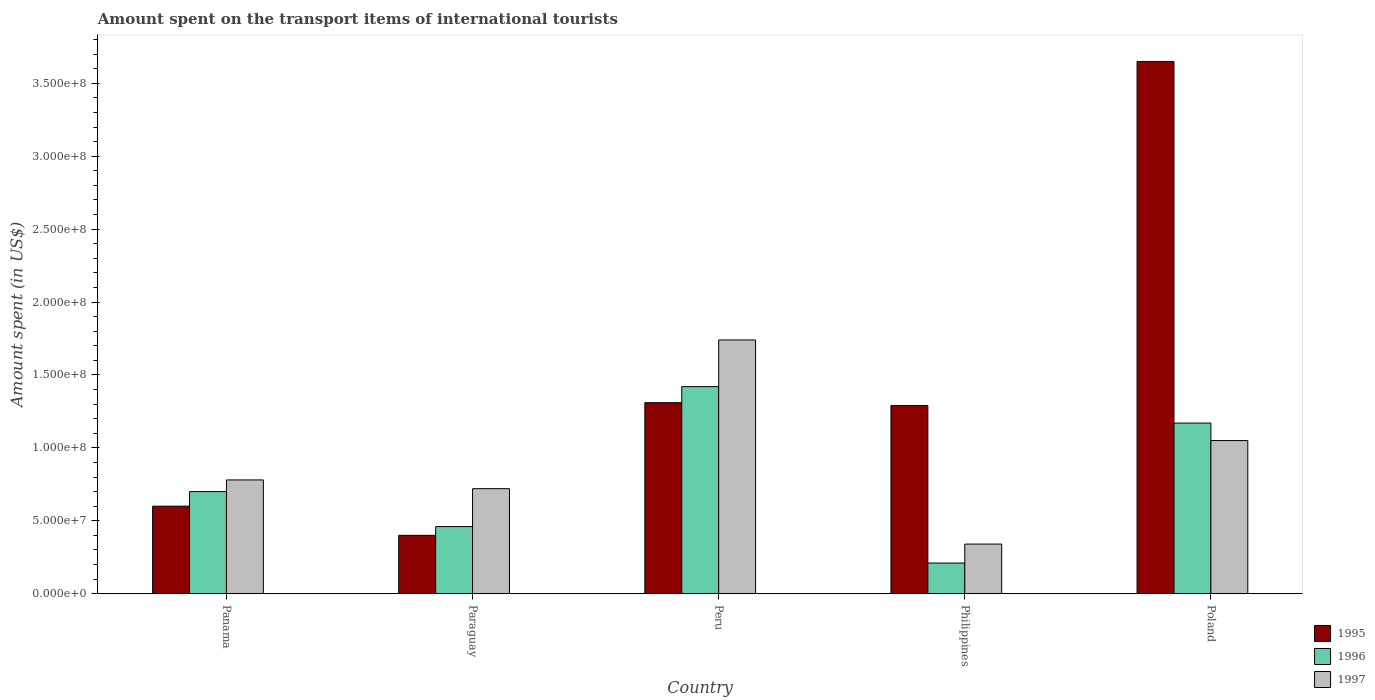Are the number of bars on each tick of the X-axis equal?
Keep it short and to the point. Yes. In how many cases, is the number of bars for a given country not equal to the number of legend labels?
Give a very brief answer. 0. What is the amount spent on the transport items of international tourists in 1996 in Philippines?
Your answer should be compact. 2.10e+07. Across all countries, what is the maximum amount spent on the transport items of international tourists in 1996?
Offer a very short reply. 1.42e+08. Across all countries, what is the minimum amount spent on the transport items of international tourists in 1995?
Your answer should be compact. 4.00e+07. What is the total amount spent on the transport items of international tourists in 1997 in the graph?
Provide a short and direct response. 4.63e+08. What is the difference between the amount spent on the transport items of international tourists in 1996 in Paraguay and that in Peru?
Provide a short and direct response. -9.60e+07. What is the difference between the amount spent on the transport items of international tourists in 1995 in Paraguay and the amount spent on the transport items of international tourists in 1997 in Poland?
Offer a terse response. -6.50e+07. What is the average amount spent on the transport items of international tourists in 1997 per country?
Provide a short and direct response. 9.26e+07. What is the difference between the amount spent on the transport items of international tourists of/in 1997 and amount spent on the transport items of international tourists of/in 1995 in Philippines?
Give a very brief answer. -9.50e+07. What is the ratio of the amount spent on the transport items of international tourists in 1996 in Peru to that in Philippines?
Give a very brief answer. 6.76. Is the difference between the amount spent on the transport items of international tourists in 1997 in Panama and Philippines greater than the difference between the amount spent on the transport items of international tourists in 1995 in Panama and Philippines?
Keep it short and to the point. Yes. What is the difference between the highest and the second highest amount spent on the transport items of international tourists in 1995?
Ensure brevity in your answer.  2.36e+08. What is the difference between the highest and the lowest amount spent on the transport items of international tourists in 1996?
Make the answer very short. 1.21e+08. In how many countries, is the amount spent on the transport items of international tourists in 1995 greater than the average amount spent on the transport items of international tourists in 1995 taken over all countries?
Keep it short and to the point. 1. Is the sum of the amount spent on the transport items of international tourists in 1997 in Panama and Poland greater than the maximum amount spent on the transport items of international tourists in 1995 across all countries?
Keep it short and to the point. No. What does the 3rd bar from the right in Panama represents?
Your answer should be very brief. 1995. Is it the case that in every country, the sum of the amount spent on the transport items of international tourists in 1997 and amount spent on the transport items of international tourists in 1995 is greater than the amount spent on the transport items of international tourists in 1996?
Offer a terse response. Yes. How many bars are there?
Offer a terse response. 15. What is the difference between two consecutive major ticks on the Y-axis?
Ensure brevity in your answer.  5.00e+07. What is the title of the graph?
Make the answer very short. Amount spent on the transport items of international tourists. Does "2006" appear as one of the legend labels in the graph?
Keep it short and to the point. No. What is the label or title of the X-axis?
Provide a short and direct response. Country. What is the label or title of the Y-axis?
Provide a short and direct response. Amount spent (in US$). What is the Amount spent (in US$) of 1995 in Panama?
Ensure brevity in your answer.  6.00e+07. What is the Amount spent (in US$) of 1996 in Panama?
Offer a very short reply. 7.00e+07. What is the Amount spent (in US$) in 1997 in Panama?
Keep it short and to the point. 7.80e+07. What is the Amount spent (in US$) of 1995 in Paraguay?
Keep it short and to the point. 4.00e+07. What is the Amount spent (in US$) in 1996 in Paraguay?
Offer a terse response. 4.60e+07. What is the Amount spent (in US$) of 1997 in Paraguay?
Ensure brevity in your answer.  7.20e+07. What is the Amount spent (in US$) of 1995 in Peru?
Provide a short and direct response. 1.31e+08. What is the Amount spent (in US$) in 1996 in Peru?
Ensure brevity in your answer.  1.42e+08. What is the Amount spent (in US$) of 1997 in Peru?
Keep it short and to the point. 1.74e+08. What is the Amount spent (in US$) in 1995 in Philippines?
Ensure brevity in your answer.  1.29e+08. What is the Amount spent (in US$) in 1996 in Philippines?
Your response must be concise. 2.10e+07. What is the Amount spent (in US$) of 1997 in Philippines?
Offer a very short reply. 3.40e+07. What is the Amount spent (in US$) in 1995 in Poland?
Provide a short and direct response. 3.65e+08. What is the Amount spent (in US$) in 1996 in Poland?
Provide a short and direct response. 1.17e+08. What is the Amount spent (in US$) in 1997 in Poland?
Offer a very short reply. 1.05e+08. Across all countries, what is the maximum Amount spent (in US$) in 1995?
Your response must be concise. 3.65e+08. Across all countries, what is the maximum Amount spent (in US$) in 1996?
Your answer should be compact. 1.42e+08. Across all countries, what is the maximum Amount spent (in US$) of 1997?
Ensure brevity in your answer.  1.74e+08. Across all countries, what is the minimum Amount spent (in US$) in 1995?
Your response must be concise. 4.00e+07. Across all countries, what is the minimum Amount spent (in US$) in 1996?
Offer a very short reply. 2.10e+07. Across all countries, what is the minimum Amount spent (in US$) of 1997?
Give a very brief answer. 3.40e+07. What is the total Amount spent (in US$) in 1995 in the graph?
Provide a succinct answer. 7.25e+08. What is the total Amount spent (in US$) of 1996 in the graph?
Offer a very short reply. 3.96e+08. What is the total Amount spent (in US$) in 1997 in the graph?
Make the answer very short. 4.63e+08. What is the difference between the Amount spent (in US$) of 1995 in Panama and that in Paraguay?
Provide a succinct answer. 2.00e+07. What is the difference between the Amount spent (in US$) of 1996 in Panama and that in Paraguay?
Give a very brief answer. 2.40e+07. What is the difference between the Amount spent (in US$) in 1997 in Panama and that in Paraguay?
Ensure brevity in your answer.  6.00e+06. What is the difference between the Amount spent (in US$) of 1995 in Panama and that in Peru?
Offer a very short reply. -7.10e+07. What is the difference between the Amount spent (in US$) of 1996 in Panama and that in Peru?
Offer a very short reply. -7.20e+07. What is the difference between the Amount spent (in US$) in 1997 in Panama and that in Peru?
Provide a succinct answer. -9.60e+07. What is the difference between the Amount spent (in US$) of 1995 in Panama and that in Philippines?
Provide a succinct answer. -6.90e+07. What is the difference between the Amount spent (in US$) in 1996 in Panama and that in Philippines?
Keep it short and to the point. 4.90e+07. What is the difference between the Amount spent (in US$) in 1997 in Panama and that in Philippines?
Your answer should be compact. 4.40e+07. What is the difference between the Amount spent (in US$) of 1995 in Panama and that in Poland?
Keep it short and to the point. -3.05e+08. What is the difference between the Amount spent (in US$) of 1996 in Panama and that in Poland?
Your answer should be compact. -4.70e+07. What is the difference between the Amount spent (in US$) in 1997 in Panama and that in Poland?
Your answer should be compact. -2.70e+07. What is the difference between the Amount spent (in US$) in 1995 in Paraguay and that in Peru?
Your answer should be compact. -9.10e+07. What is the difference between the Amount spent (in US$) in 1996 in Paraguay and that in Peru?
Give a very brief answer. -9.60e+07. What is the difference between the Amount spent (in US$) in 1997 in Paraguay and that in Peru?
Give a very brief answer. -1.02e+08. What is the difference between the Amount spent (in US$) of 1995 in Paraguay and that in Philippines?
Your answer should be compact. -8.90e+07. What is the difference between the Amount spent (in US$) of 1996 in Paraguay and that in Philippines?
Offer a very short reply. 2.50e+07. What is the difference between the Amount spent (in US$) of 1997 in Paraguay and that in Philippines?
Provide a succinct answer. 3.80e+07. What is the difference between the Amount spent (in US$) of 1995 in Paraguay and that in Poland?
Make the answer very short. -3.25e+08. What is the difference between the Amount spent (in US$) in 1996 in Paraguay and that in Poland?
Your answer should be very brief. -7.10e+07. What is the difference between the Amount spent (in US$) of 1997 in Paraguay and that in Poland?
Make the answer very short. -3.30e+07. What is the difference between the Amount spent (in US$) in 1995 in Peru and that in Philippines?
Give a very brief answer. 2.00e+06. What is the difference between the Amount spent (in US$) of 1996 in Peru and that in Philippines?
Your response must be concise. 1.21e+08. What is the difference between the Amount spent (in US$) in 1997 in Peru and that in Philippines?
Your response must be concise. 1.40e+08. What is the difference between the Amount spent (in US$) of 1995 in Peru and that in Poland?
Offer a very short reply. -2.34e+08. What is the difference between the Amount spent (in US$) of 1996 in Peru and that in Poland?
Keep it short and to the point. 2.50e+07. What is the difference between the Amount spent (in US$) of 1997 in Peru and that in Poland?
Make the answer very short. 6.90e+07. What is the difference between the Amount spent (in US$) of 1995 in Philippines and that in Poland?
Make the answer very short. -2.36e+08. What is the difference between the Amount spent (in US$) of 1996 in Philippines and that in Poland?
Give a very brief answer. -9.60e+07. What is the difference between the Amount spent (in US$) in 1997 in Philippines and that in Poland?
Ensure brevity in your answer.  -7.10e+07. What is the difference between the Amount spent (in US$) of 1995 in Panama and the Amount spent (in US$) of 1996 in Paraguay?
Your answer should be very brief. 1.40e+07. What is the difference between the Amount spent (in US$) of 1995 in Panama and the Amount spent (in US$) of 1997 in Paraguay?
Provide a short and direct response. -1.20e+07. What is the difference between the Amount spent (in US$) in 1996 in Panama and the Amount spent (in US$) in 1997 in Paraguay?
Offer a terse response. -2.00e+06. What is the difference between the Amount spent (in US$) in 1995 in Panama and the Amount spent (in US$) in 1996 in Peru?
Offer a terse response. -8.20e+07. What is the difference between the Amount spent (in US$) in 1995 in Panama and the Amount spent (in US$) in 1997 in Peru?
Give a very brief answer. -1.14e+08. What is the difference between the Amount spent (in US$) in 1996 in Panama and the Amount spent (in US$) in 1997 in Peru?
Keep it short and to the point. -1.04e+08. What is the difference between the Amount spent (in US$) of 1995 in Panama and the Amount spent (in US$) of 1996 in Philippines?
Offer a very short reply. 3.90e+07. What is the difference between the Amount spent (in US$) in 1995 in Panama and the Amount spent (in US$) in 1997 in Philippines?
Offer a very short reply. 2.60e+07. What is the difference between the Amount spent (in US$) of 1996 in Panama and the Amount spent (in US$) of 1997 in Philippines?
Offer a terse response. 3.60e+07. What is the difference between the Amount spent (in US$) of 1995 in Panama and the Amount spent (in US$) of 1996 in Poland?
Your answer should be very brief. -5.70e+07. What is the difference between the Amount spent (in US$) in 1995 in Panama and the Amount spent (in US$) in 1997 in Poland?
Make the answer very short. -4.50e+07. What is the difference between the Amount spent (in US$) of 1996 in Panama and the Amount spent (in US$) of 1997 in Poland?
Provide a succinct answer. -3.50e+07. What is the difference between the Amount spent (in US$) of 1995 in Paraguay and the Amount spent (in US$) of 1996 in Peru?
Your answer should be very brief. -1.02e+08. What is the difference between the Amount spent (in US$) of 1995 in Paraguay and the Amount spent (in US$) of 1997 in Peru?
Provide a short and direct response. -1.34e+08. What is the difference between the Amount spent (in US$) of 1996 in Paraguay and the Amount spent (in US$) of 1997 in Peru?
Ensure brevity in your answer.  -1.28e+08. What is the difference between the Amount spent (in US$) in 1995 in Paraguay and the Amount spent (in US$) in 1996 in Philippines?
Offer a very short reply. 1.90e+07. What is the difference between the Amount spent (in US$) in 1995 in Paraguay and the Amount spent (in US$) in 1997 in Philippines?
Make the answer very short. 6.00e+06. What is the difference between the Amount spent (in US$) of 1995 in Paraguay and the Amount spent (in US$) of 1996 in Poland?
Your response must be concise. -7.70e+07. What is the difference between the Amount spent (in US$) of 1995 in Paraguay and the Amount spent (in US$) of 1997 in Poland?
Offer a terse response. -6.50e+07. What is the difference between the Amount spent (in US$) of 1996 in Paraguay and the Amount spent (in US$) of 1997 in Poland?
Your answer should be very brief. -5.90e+07. What is the difference between the Amount spent (in US$) in 1995 in Peru and the Amount spent (in US$) in 1996 in Philippines?
Your answer should be compact. 1.10e+08. What is the difference between the Amount spent (in US$) in 1995 in Peru and the Amount spent (in US$) in 1997 in Philippines?
Make the answer very short. 9.70e+07. What is the difference between the Amount spent (in US$) in 1996 in Peru and the Amount spent (in US$) in 1997 in Philippines?
Make the answer very short. 1.08e+08. What is the difference between the Amount spent (in US$) in 1995 in Peru and the Amount spent (in US$) in 1996 in Poland?
Provide a short and direct response. 1.40e+07. What is the difference between the Amount spent (in US$) of 1995 in Peru and the Amount spent (in US$) of 1997 in Poland?
Offer a very short reply. 2.60e+07. What is the difference between the Amount spent (in US$) of 1996 in Peru and the Amount spent (in US$) of 1997 in Poland?
Ensure brevity in your answer.  3.70e+07. What is the difference between the Amount spent (in US$) in 1995 in Philippines and the Amount spent (in US$) in 1996 in Poland?
Your response must be concise. 1.20e+07. What is the difference between the Amount spent (in US$) in 1995 in Philippines and the Amount spent (in US$) in 1997 in Poland?
Make the answer very short. 2.40e+07. What is the difference between the Amount spent (in US$) in 1996 in Philippines and the Amount spent (in US$) in 1997 in Poland?
Your answer should be compact. -8.40e+07. What is the average Amount spent (in US$) in 1995 per country?
Your response must be concise. 1.45e+08. What is the average Amount spent (in US$) in 1996 per country?
Provide a succinct answer. 7.92e+07. What is the average Amount spent (in US$) of 1997 per country?
Provide a short and direct response. 9.26e+07. What is the difference between the Amount spent (in US$) in 1995 and Amount spent (in US$) in 1996 in Panama?
Keep it short and to the point. -1.00e+07. What is the difference between the Amount spent (in US$) of 1995 and Amount spent (in US$) of 1997 in Panama?
Make the answer very short. -1.80e+07. What is the difference between the Amount spent (in US$) in 1996 and Amount spent (in US$) in 1997 in Panama?
Offer a terse response. -8.00e+06. What is the difference between the Amount spent (in US$) in 1995 and Amount spent (in US$) in 1996 in Paraguay?
Provide a succinct answer. -6.00e+06. What is the difference between the Amount spent (in US$) in 1995 and Amount spent (in US$) in 1997 in Paraguay?
Keep it short and to the point. -3.20e+07. What is the difference between the Amount spent (in US$) in 1996 and Amount spent (in US$) in 1997 in Paraguay?
Your answer should be compact. -2.60e+07. What is the difference between the Amount spent (in US$) of 1995 and Amount spent (in US$) of 1996 in Peru?
Your answer should be very brief. -1.10e+07. What is the difference between the Amount spent (in US$) of 1995 and Amount spent (in US$) of 1997 in Peru?
Your answer should be very brief. -4.30e+07. What is the difference between the Amount spent (in US$) in 1996 and Amount spent (in US$) in 1997 in Peru?
Offer a terse response. -3.20e+07. What is the difference between the Amount spent (in US$) in 1995 and Amount spent (in US$) in 1996 in Philippines?
Your answer should be very brief. 1.08e+08. What is the difference between the Amount spent (in US$) in 1995 and Amount spent (in US$) in 1997 in Philippines?
Your answer should be very brief. 9.50e+07. What is the difference between the Amount spent (in US$) in 1996 and Amount spent (in US$) in 1997 in Philippines?
Your answer should be very brief. -1.30e+07. What is the difference between the Amount spent (in US$) in 1995 and Amount spent (in US$) in 1996 in Poland?
Make the answer very short. 2.48e+08. What is the difference between the Amount spent (in US$) in 1995 and Amount spent (in US$) in 1997 in Poland?
Provide a short and direct response. 2.60e+08. What is the difference between the Amount spent (in US$) in 1996 and Amount spent (in US$) in 1997 in Poland?
Offer a very short reply. 1.20e+07. What is the ratio of the Amount spent (in US$) of 1996 in Panama to that in Paraguay?
Give a very brief answer. 1.52. What is the ratio of the Amount spent (in US$) in 1995 in Panama to that in Peru?
Make the answer very short. 0.46. What is the ratio of the Amount spent (in US$) in 1996 in Panama to that in Peru?
Your answer should be very brief. 0.49. What is the ratio of the Amount spent (in US$) of 1997 in Panama to that in Peru?
Offer a terse response. 0.45. What is the ratio of the Amount spent (in US$) of 1995 in Panama to that in Philippines?
Keep it short and to the point. 0.47. What is the ratio of the Amount spent (in US$) of 1997 in Panama to that in Philippines?
Make the answer very short. 2.29. What is the ratio of the Amount spent (in US$) in 1995 in Panama to that in Poland?
Keep it short and to the point. 0.16. What is the ratio of the Amount spent (in US$) in 1996 in Panama to that in Poland?
Your response must be concise. 0.6. What is the ratio of the Amount spent (in US$) in 1997 in Panama to that in Poland?
Offer a very short reply. 0.74. What is the ratio of the Amount spent (in US$) in 1995 in Paraguay to that in Peru?
Offer a very short reply. 0.31. What is the ratio of the Amount spent (in US$) in 1996 in Paraguay to that in Peru?
Your response must be concise. 0.32. What is the ratio of the Amount spent (in US$) in 1997 in Paraguay to that in Peru?
Provide a short and direct response. 0.41. What is the ratio of the Amount spent (in US$) of 1995 in Paraguay to that in Philippines?
Provide a short and direct response. 0.31. What is the ratio of the Amount spent (in US$) in 1996 in Paraguay to that in Philippines?
Ensure brevity in your answer.  2.19. What is the ratio of the Amount spent (in US$) in 1997 in Paraguay to that in Philippines?
Make the answer very short. 2.12. What is the ratio of the Amount spent (in US$) in 1995 in Paraguay to that in Poland?
Your response must be concise. 0.11. What is the ratio of the Amount spent (in US$) in 1996 in Paraguay to that in Poland?
Ensure brevity in your answer.  0.39. What is the ratio of the Amount spent (in US$) of 1997 in Paraguay to that in Poland?
Make the answer very short. 0.69. What is the ratio of the Amount spent (in US$) of 1995 in Peru to that in Philippines?
Make the answer very short. 1.02. What is the ratio of the Amount spent (in US$) of 1996 in Peru to that in Philippines?
Give a very brief answer. 6.76. What is the ratio of the Amount spent (in US$) of 1997 in Peru to that in Philippines?
Your response must be concise. 5.12. What is the ratio of the Amount spent (in US$) in 1995 in Peru to that in Poland?
Provide a short and direct response. 0.36. What is the ratio of the Amount spent (in US$) in 1996 in Peru to that in Poland?
Make the answer very short. 1.21. What is the ratio of the Amount spent (in US$) in 1997 in Peru to that in Poland?
Ensure brevity in your answer.  1.66. What is the ratio of the Amount spent (in US$) of 1995 in Philippines to that in Poland?
Keep it short and to the point. 0.35. What is the ratio of the Amount spent (in US$) of 1996 in Philippines to that in Poland?
Keep it short and to the point. 0.18. What is the ratio of the Amount spent (in US$) of 1997 in Philippines to that in Poland?
Give a very brief answer. 0.32. What is the difference between the highest and the second highest Amount spent (in US$) of 1995?
Give a very brief answer. 2.34e+08. What is the difference between the highest and the second highest Amount spent (in US$) of 1996?
Keep it short and to the point. 2.50e+07. What is the difference between the highest and the second highest Amount spent (in US$) in 1997?
Make the answer very short. 6.90e+07. What is the difference between the highest and the lowest Amount spent (in US$) in 1995?
Make the answer very short. 3.25e+08. What is the difference between the highest and the lowest Amount spent (in US$) in 1996?
Offer a very short reply. 1.21e+08. What is the difference between the highest and the lowest Amount spent (in US$) of 1997?
Make the answer very short. 1.40e+08. 